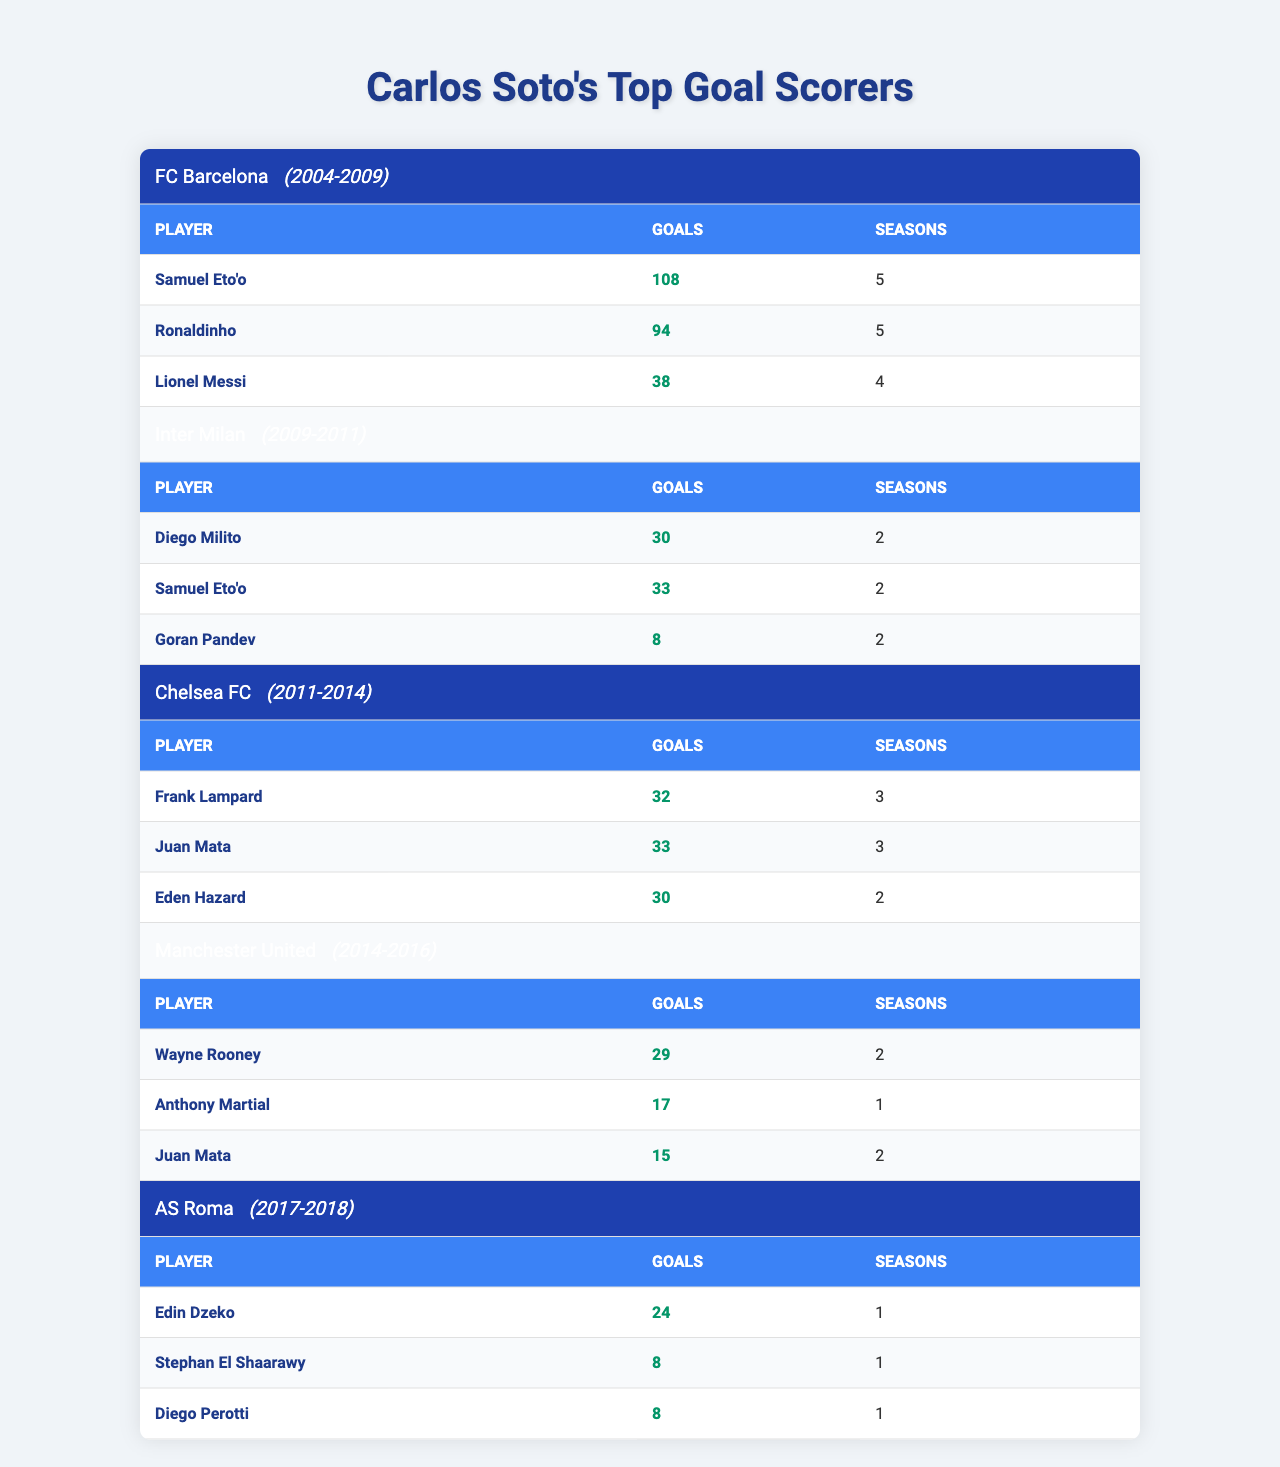What's the total number of goals scored by Samuel Eto'o at FC Barcelona? Samuel Eto'o scored 108 goals during his time at FC Barcelona.
Answer: 108 Which player scored the most goals at Chelsea FC? Juan Mata scored the most goals at Chelsea FC with 33 goals.
Answer: Juan Mata How many seasons did Wayne Rooney play for Manchester United? Wayne Rooney played for Manchester United for 2 seasons.
Answer: 2 What is the combined total of goals scored by the top three goal scorers at Inter Milan? Diego Milito scored 30 goals, Samuel Eto'o scored 33 goals, and Goran Pandev scored 8 goals. The total is 30 + 33 + 8 = 71.
Answer: 71 Did Lionel Messi score more goals than Ronaldinho at FC Barcelona? Lionel Messi scored 38 goals, while Ronaldinho scored 94 goals, so Ronaldinho scored more.
Answer: No What is the average number of goals scored by the top scorers in AS Roma? Edin Dzeko scored 24 goals, and the other two players scored 8 goals each. The total is 24 + 8 + 8 = 40, and there are 3 players, so the average is 40/3 = 13.33.
Answer: 13.33 How many goals did Eden Hazard score at Chelsea FC compared to Frank Lampard? Eden Hazard scored 30 goals, while Frank Lampard scored 32 goals. Frank Lampard scored 2 more goals than Hazard.
Answer: 2 Which team had the highest total number of goals scored by their top goal scorers? The total goals for FC Barcelona is 108 + 94 + 38 = 240, Inter Milan is 30 + 33 + 8 = 71, Chelsea FC is 32 + 33 + 30 = 95, Manchester United is 29 + 17 + 15 = 61, and AS Roma is 24 + 8 + 8 = 40. FC Barcelona had the highest total of 240 goals.
Answer: FC Barcelona How many total goals did players score in their last season at their respective clubs? At Inter Milan (Goran Pandev: 8), Chelsea FC (Eden Hazard: 30), Manchester United (Anthony Martial: 17), and AS Roma (Edin Dzeko: 24), the total is 8 + 30 + 17 + 24 = 79.
Answer: 79 Is the number of seasons played by the top scorers at FC Barcelona greater than the total goals they scored? The total number of seasons is 5 (Samuel Eto'o) + 5 (Ronaldinho) + 4 (Lionel Messi) = 14, which is less than the total goals scored (240), so the comparison is true.
Answer: Yes 